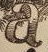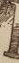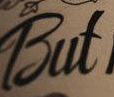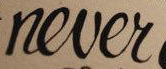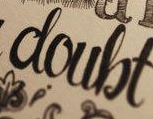What words are shown in these images in order, separated by a semicolon? a; #; But; never; doubt 